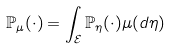Convert formula to latex. <formula><loc_0><loc_0><loc_500><loc_500>\mathbb { P } _ { \mu } ( \cdot ) = \int _ { \mathcal { E } } \mathbb { P } _ { \eta } ( \cdot ) \mu ( d \eta )</formula> 